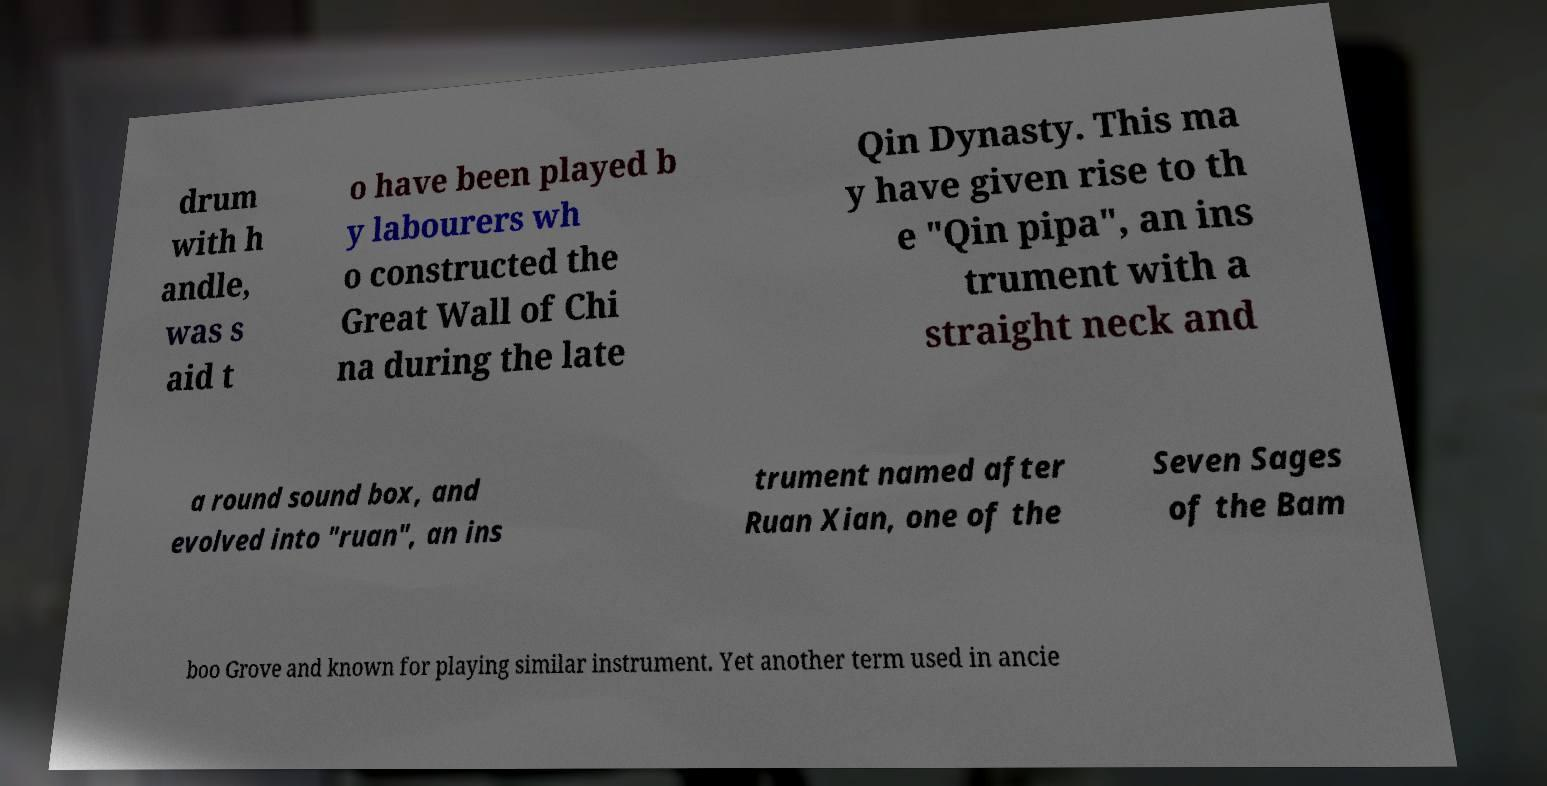There's text embedded in this image that I need extracted. Can you transcribe it verbatim? drum with h andle, was s aid t o have been played b y labourers wh o constructed the Great Wall of Chi na during the late Qin Dynasty. This ma y have given rise to th e "Qin pipa", an ins trument with a straight neck and a round sound box, and evolved into "ruan", an ins trument named after Ruan Xian, one of the Seven Sages of the Bam boo Grove and known for playing similar instrument. Yet another term used in ancie 